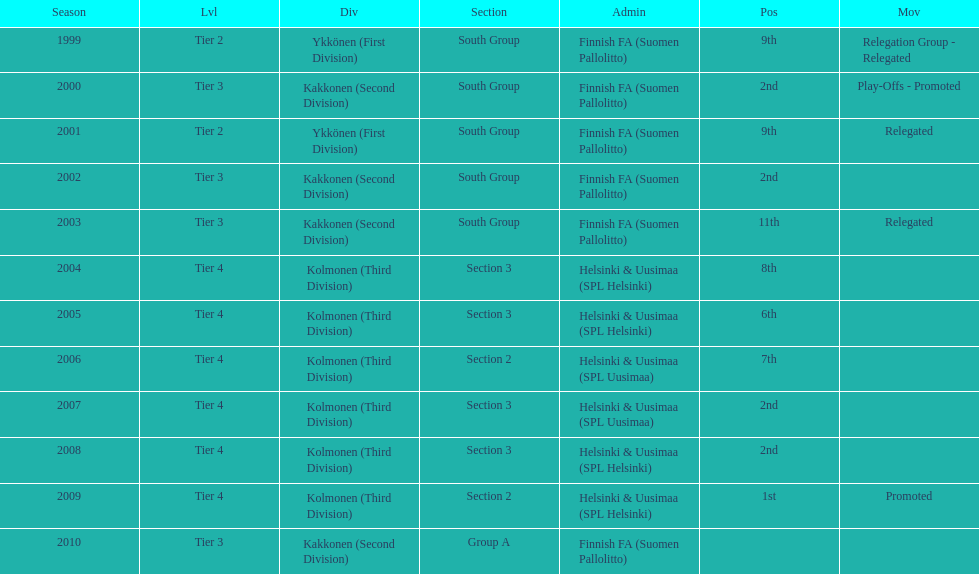How many times has this team been relegated? 3. 